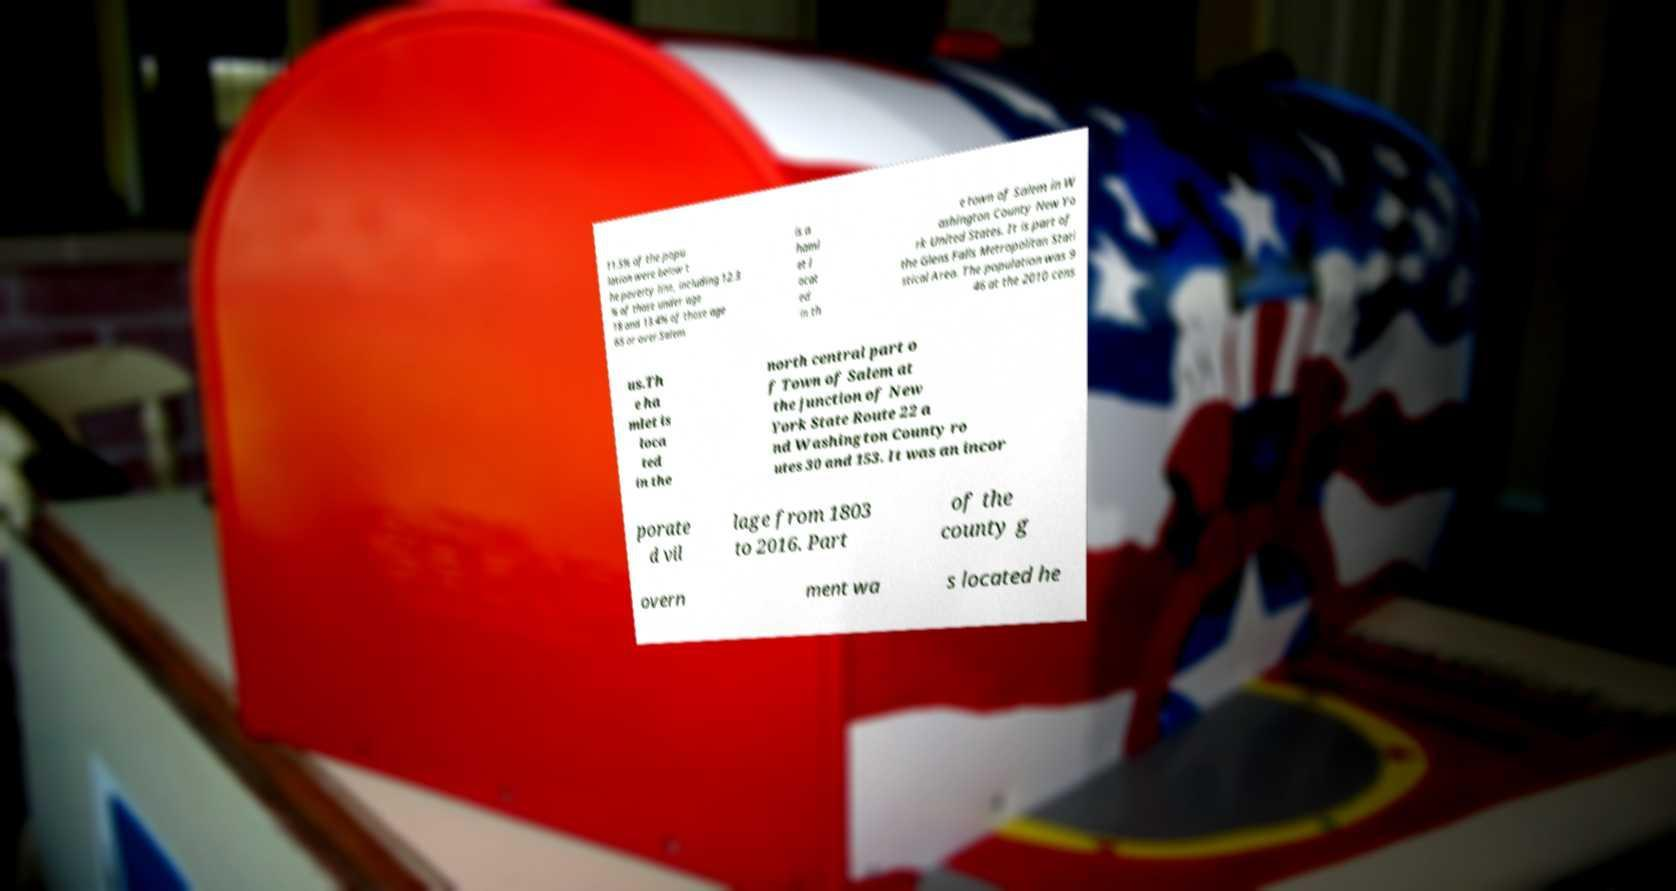Please identify and transcribe the text found in this image. 11.5% of the popu lation were below t he poverty line, including 12.3 % of those under age 18 and 13.4% of those age 65 or over.Salem is a haml et l ocat ed in th e town of Salem in W ashington County New Yo rk United States. It is part of the Glens Falls Metropolitan Stati stical Area. The population was 9 46 at the 2010 cens us.Th e ha mlet is loca ted in the north central part o f Town of Salem at the junction of New York State Route 22 a nd Washington County ro utes 30 and 153. It was an incor porate d vil lage from 1803 to 2016. Part of the county g overn ment wa s located he 